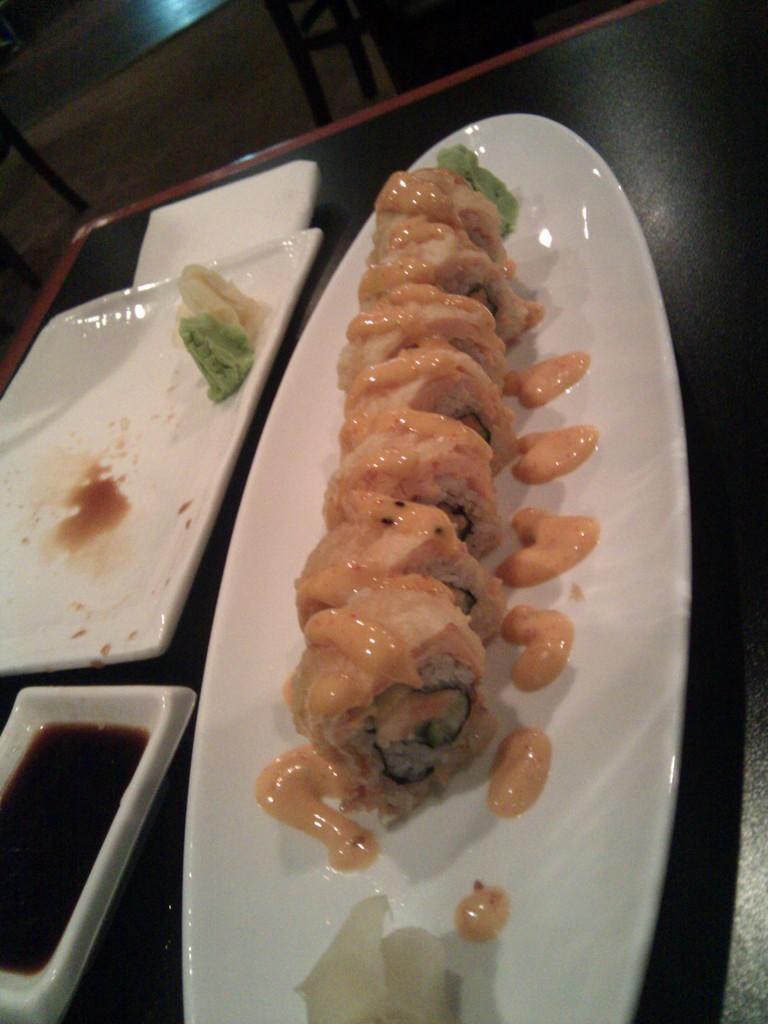Could you give a brief overview of what you see in this image? In the center of the image there are food items in the plate on the table. 